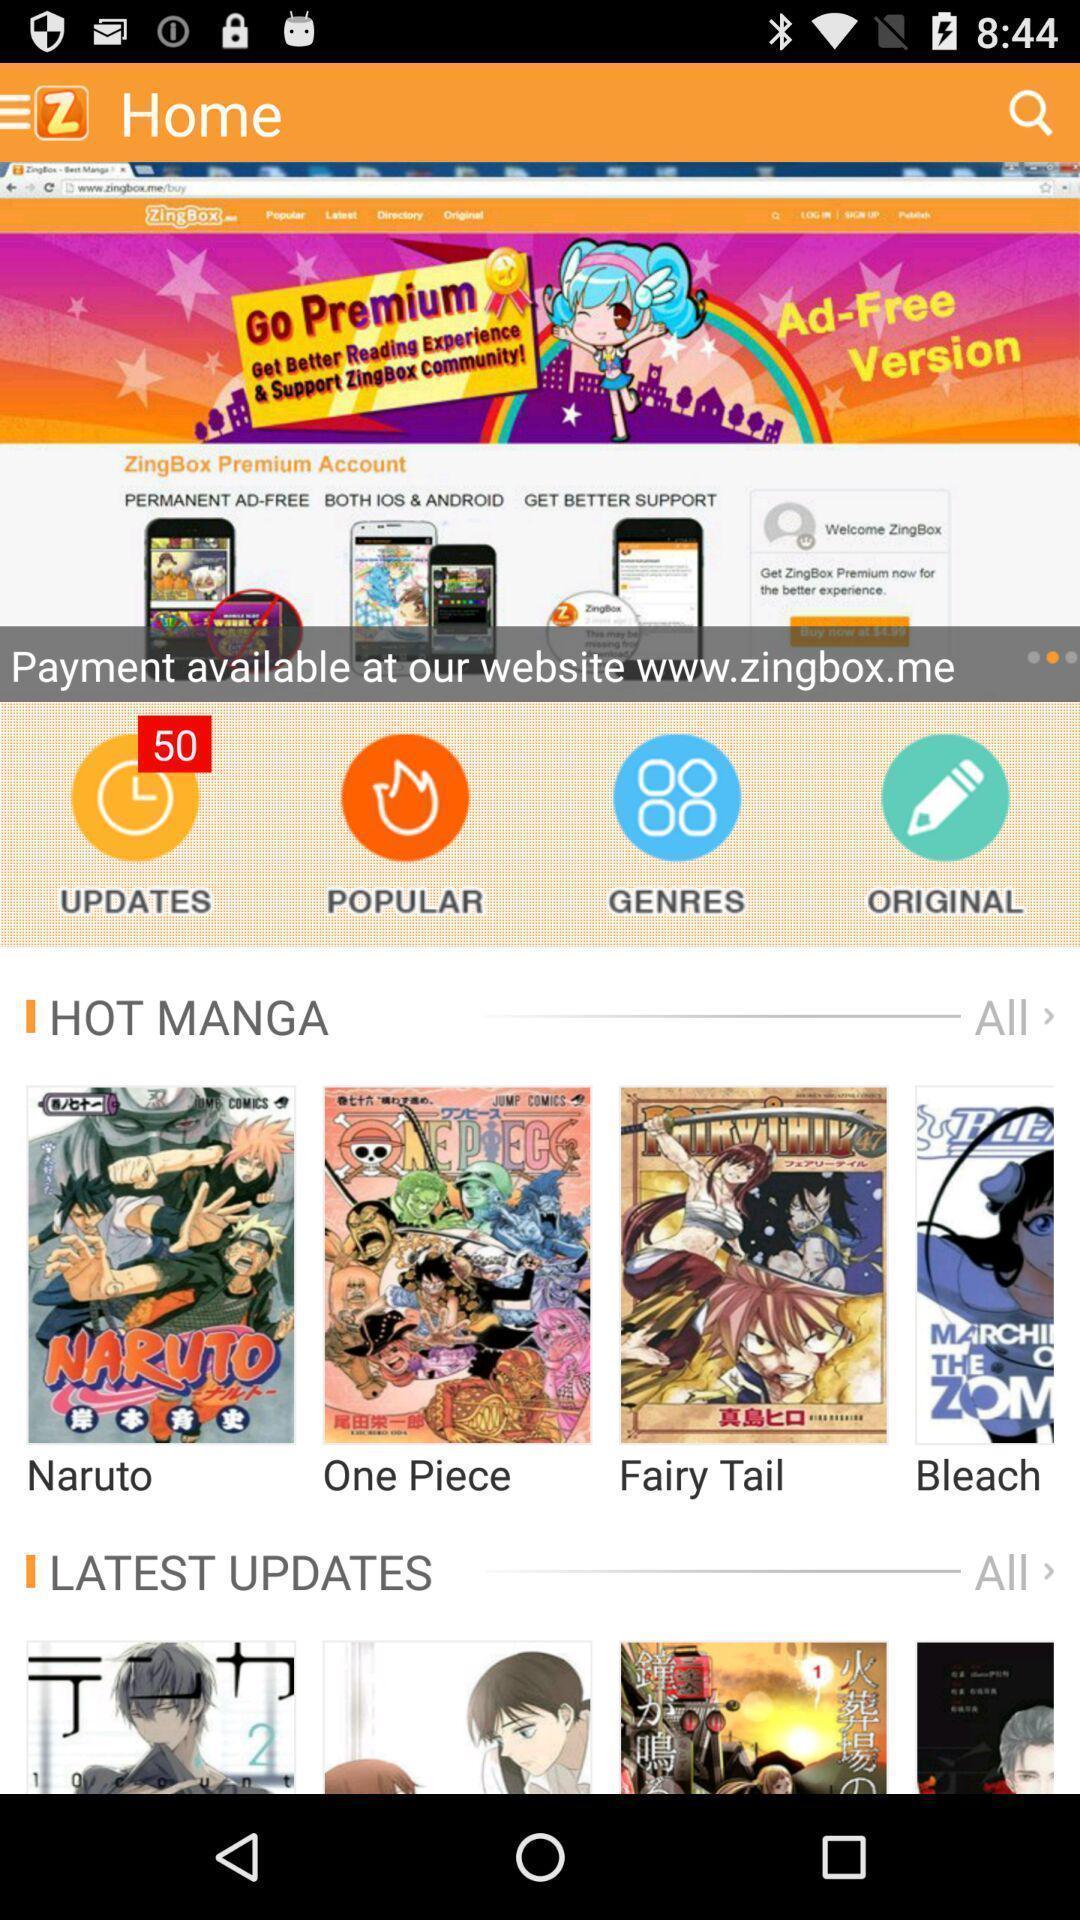Give me a narrative description of this picture. Screen displaying multiple comics in home page. 